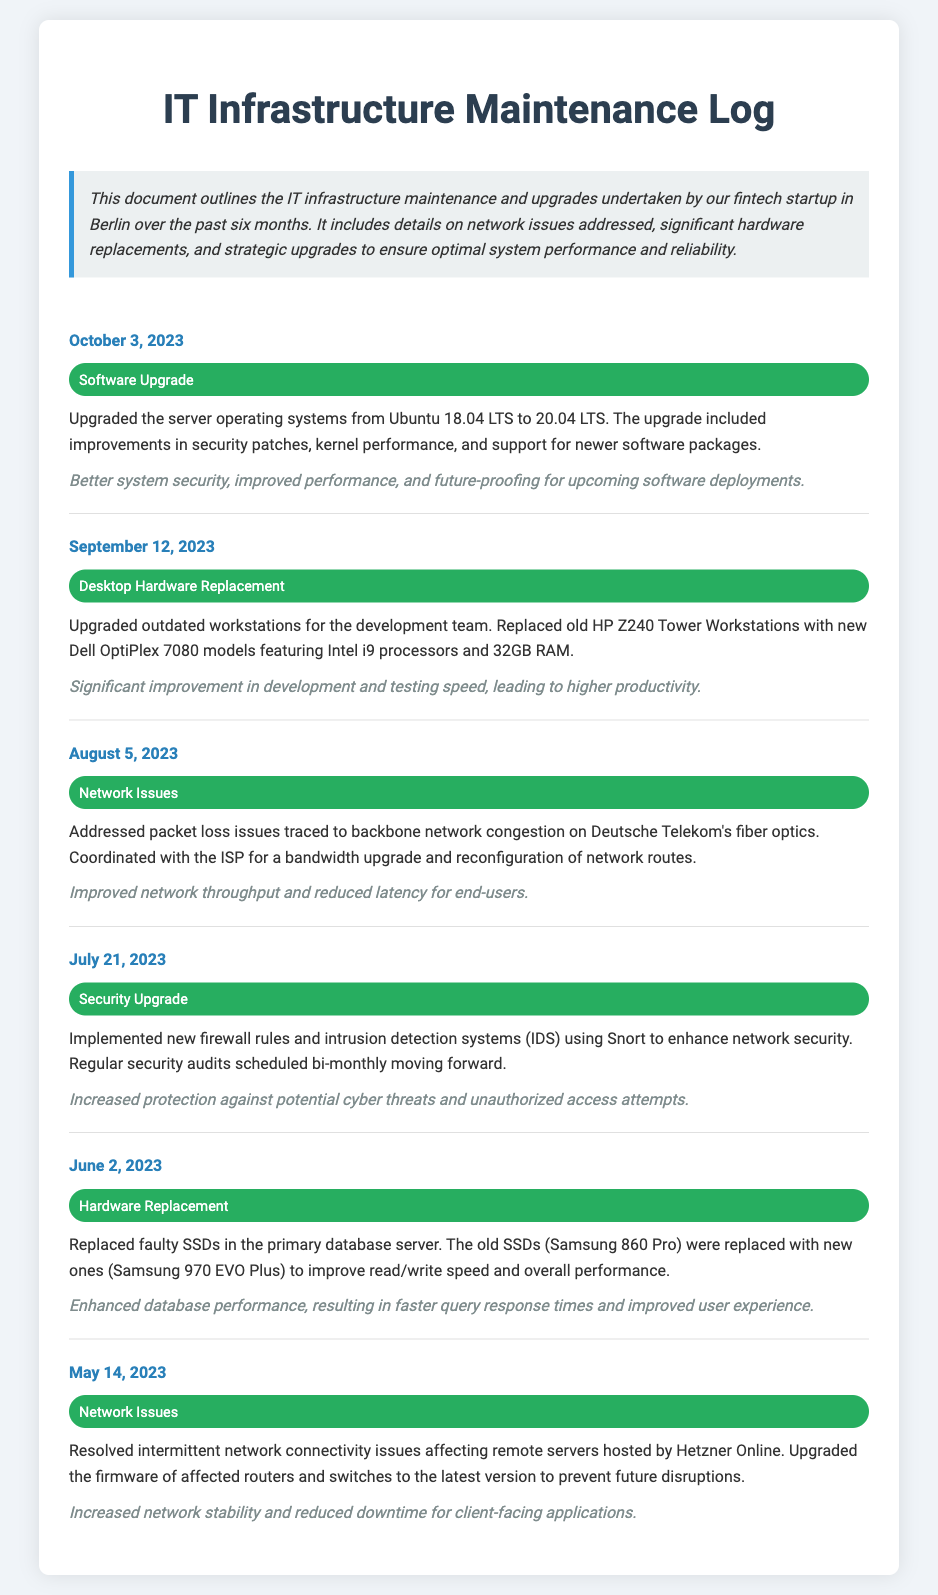What was the date of the latest software upgrade? The latest software upgrade took place on October 3, 2023, as stated in the log.
Answer: October 3, 2023 What type of security measures were implemented on July 21, 2023? The measures implemented include new firewall rules and intrusion detection systems using Snort.
Answer: Firewall rules and IDS Which hardware was replaced for the development team on September 12, 2023? The old HP Z240 Tower Workstations were replaced with new Dell OptiPlex 7080 models.
Answer: Dell OptiPlex 7080 What was the impact of addressing the network issues on August 5, 2023? The impact was improved network throughput and reduced latency for end-users.
Answer: Improved network throughput How many months does the log cover? The log covers a period from May 14, 2023, to October 3, 2023, which is a span of approximately 5 months.
Answer: 5 months What improvement occurred due to the SSD replacement on June 2, 2023? The SSD replacement resulted in enhanced database performance and faster query response times.
Answer: Enhanced database performance What is the primary purpose of the Maintenance Log? The primary purpose is to outline the IT infrastructure maintenance and upgrades undertaken over the past six months.
Answer: Outline maintenance and upgrades When were the firmware upgrades for the routers and switches completed? The firmware upgrades for the affected devices were completed on May 14, 2023.
Answer: May 14, 2023 